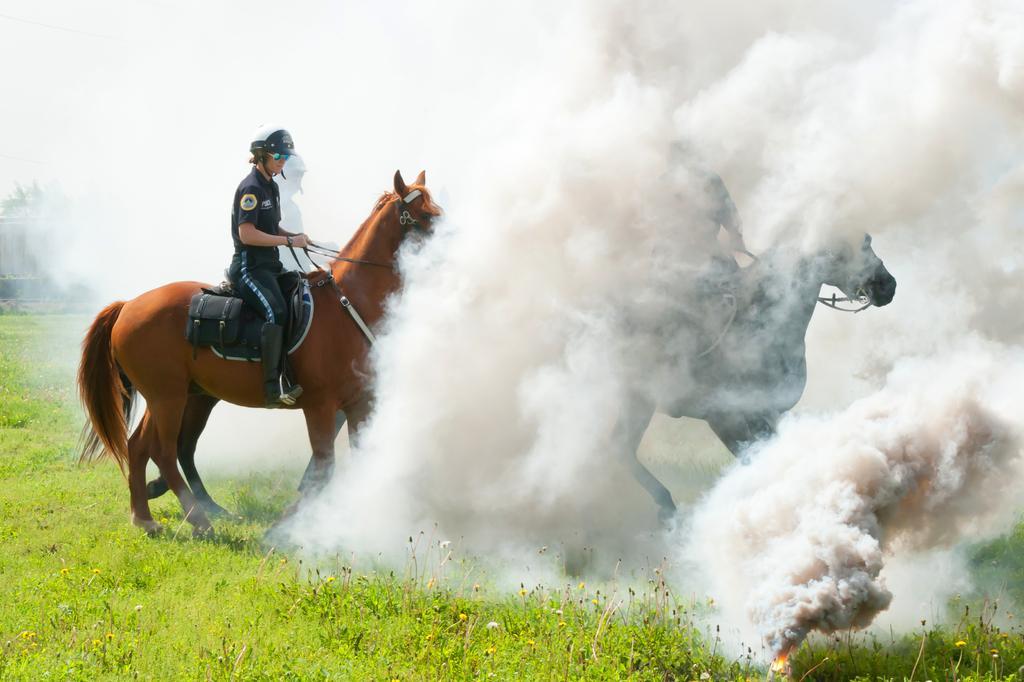What are the people doing in the image? The people are sitting on animals in the image. What type of vegetation is present in the image? There are flowers and grass in the image. What can be seen in the background of the image? There is smoke visible in the image, and the sky is also visible. How can the people control the fold of the animals in the image? There are no animals that can be folded in the image, and the people are not controlling any folding. 